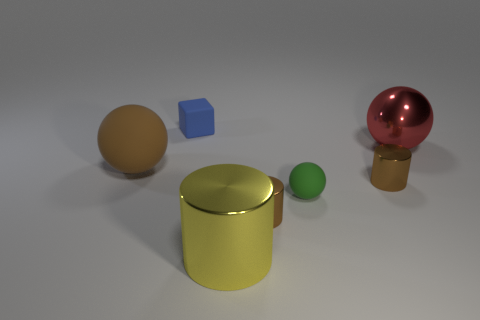Add 2 red shiny cylinders. How many objects exist? 9 Subtract all cubes. How many objects are left? 6 Add 6 big rubber objects. How many big rubber objects are left? 7 Add 6 balls. How many balls exist? 9 Subtract 0 green cylinders. How many objects are left? 7 Subtract all brown matte spheres. Subtract all small blue shiny spheres. How many objects are left? 6 